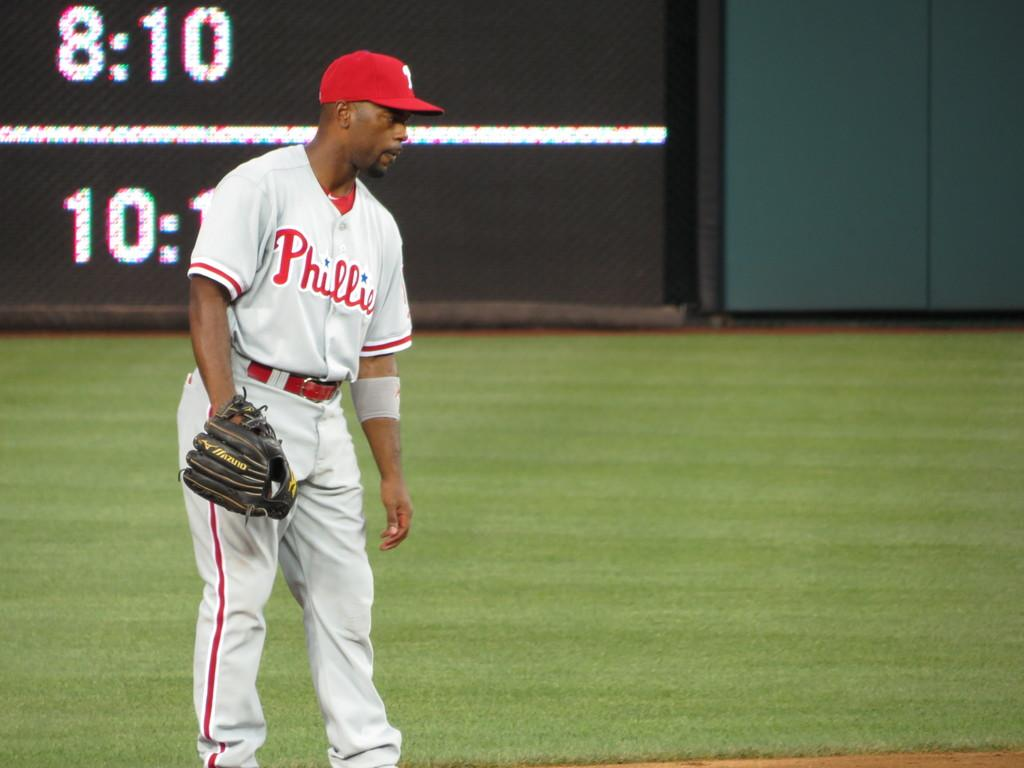<image>
Relay a brief, clear account of the picture shown. A Philadelphia Phillies player takes his glove off between plays. 